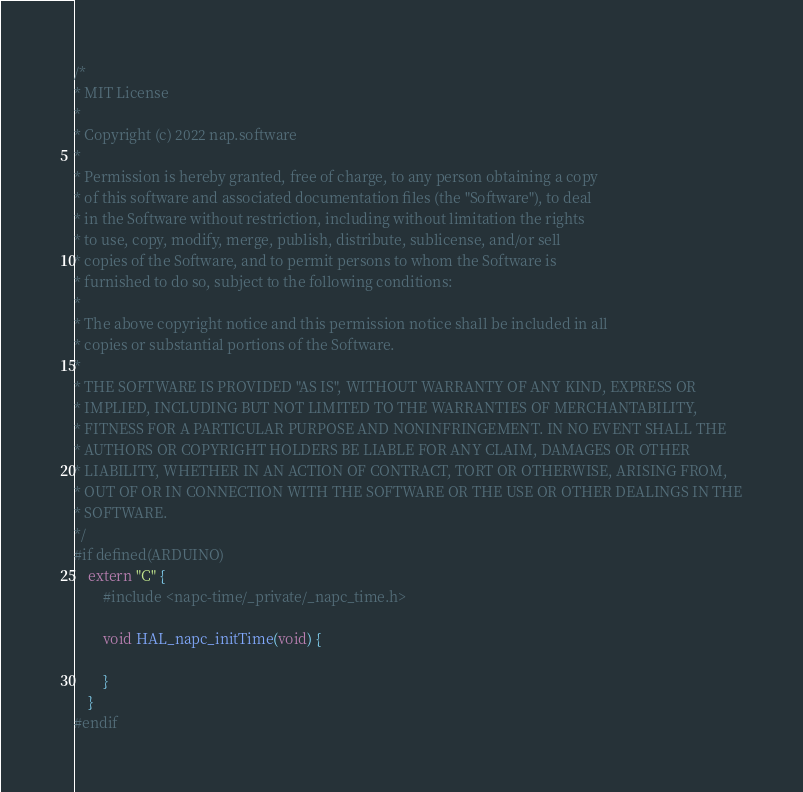<code> <loc_0><loc_0><loc_500><loc_500><_C++_>/*
* MIT License
* 
* Copyright (c) 2022 nap.software
* 
* Permission is hereby granted, free of charge, to any person obtaining a copy
* of this software and associated documentation files (the "Software"), to deal
* in the Software without restriction, including without limitation the rights
* to use, copy, modify, merge, publish, distribute, sublicense, and/or sell
* copies of the Software, and to permit persons to whom the Software is
* furnished to do so, subject to the following conditions:
* 
* The above copyright notice and this permission notice shall be included in all
* copies or substantial portions of the Software.
* 
* THE SOFTWARE IS PROVIDED "AS IS", WITHOUT WARRANTY OF ANY KIND, EXPRESS OR
* IMPLIED, INCLUDING BUT NOT LIMITED TO THE WARRANTIES OF MERCHANTABILITY,
* FITNESS FOR A PARTICULAR PURPOSE AND NONINFRINGEMENT. IN NO EVENT SHALL THE
* AUTHORS OR COPYRIGHT HOLDERS BE LIABLE FOR ANY CLAIM, DAMAGES OR OTHER
* LIABILITY, WHETHER IN AN ACTION OF CONTRACT, TORT OR OTHERWISE, ARISING FROM,
* OUT OF OR IN CONNECTION WITH THE SOFTWARE OR THE USE OR OTHER DEALINGS IN THE
* SOFTWARE.
*/
#if defined(ARDUINO)
	extern "C" {
		#include <napc-time/_private/_napc_time.h>

		void HAL_napc_initTime(void) {

		}
	}
#endif
</code> 